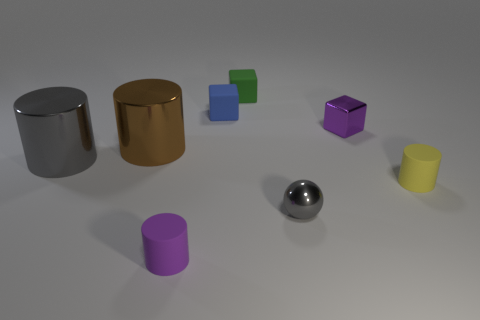There is a purple object behind the small cylinder that is left of the gray metallic thing that is in front of the large gray cylinder; what shape is it?
Make the answer very short. Cube. Does the small object that is on the right side of the purple block have the same material as the small purple thing that is left of the metallic block?
Your answer should be very brief. Yes. What is the shape of the small gray object that is the same material as the gray cylinder?
Make the answer very short. Sphere. Is there any other thing of the same color as the metallic ball?
Provide a short and direct response. Yes. How many tiny purple matte things are there?
Make the answer very short. 1. What material is the thing that is behind the matte cube to the left of the small green block?
Give a very brief answer. Rubber. What color is the large shiny cylinder that is on the left side of the big brown metallic thing left of the gray thing on the right side of the tiny green matte thing?
Make the answer very short. Gray. What number of green blocks have the same size as the green object?
Offer a terse response. 0. Is the number of matte objects left of the small yellow matte object greater than the number of blue objects in front of the tiny gray sphere?
Your answer should be very brief. Yes. What color is the matte thing that is in front of the gray metal object that is in front of the yellow object?
Provide a succinct answer. Purple. 